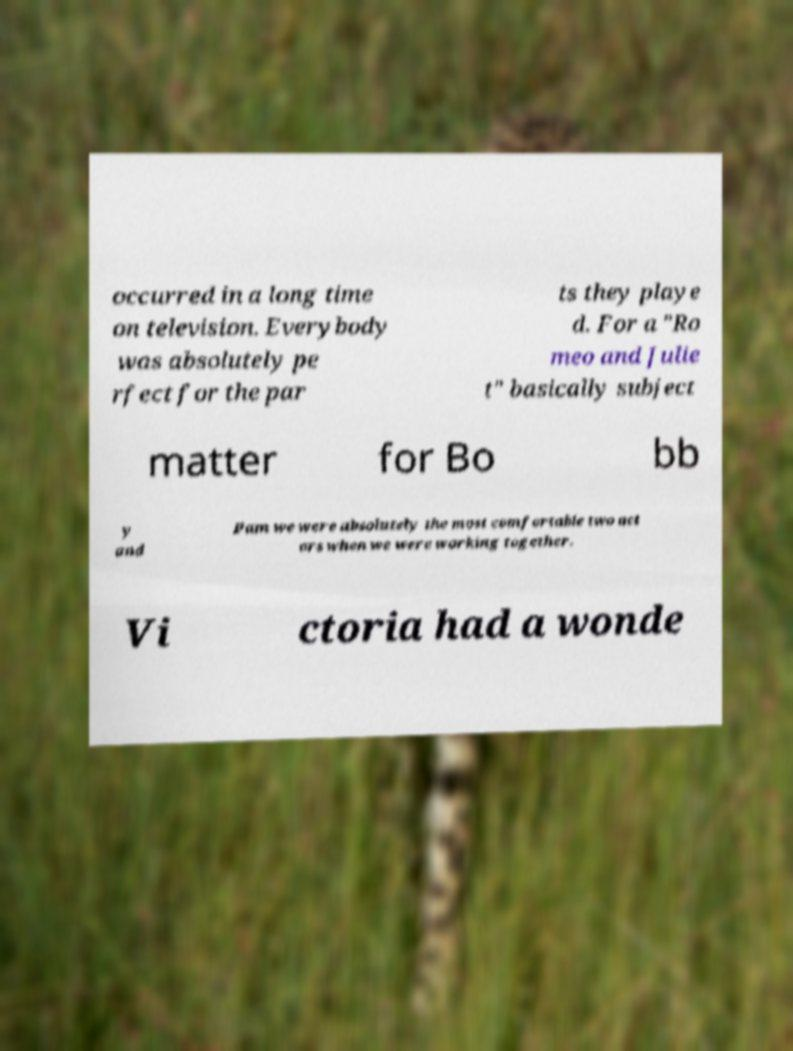Can you accurately transcribe the text from the provided image for me? occurred in a long time on television. Everybody was absolutely pe rfect for the par ts they playe d. For a "Ro meo and Julie t" basically subject matter for Bo bb y and Pam we were absolutely the most comfortable two act ors when we were working together. Vi ctoria had a wonde 